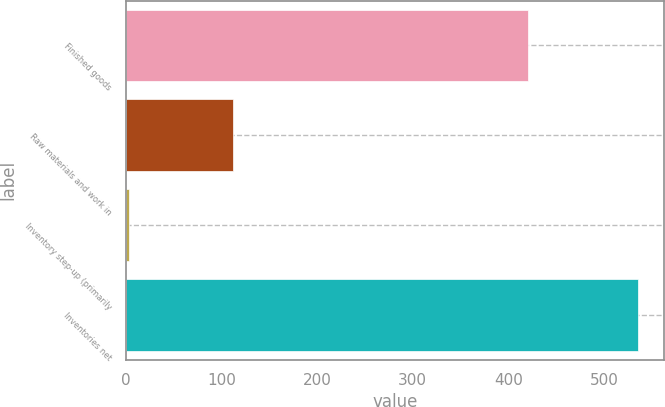Convert chart. <chart><loc_0><loc_0><loc_500><loc_500><bar_chart><fcel>Finished goods<fcel>Raw materials and work in<fcel>Inventory step-up (primarily<fcel>Inventories net<nl><fcel>420.5<fcel>112.2<fcel>3.3<fcel>536<nl></chart> 